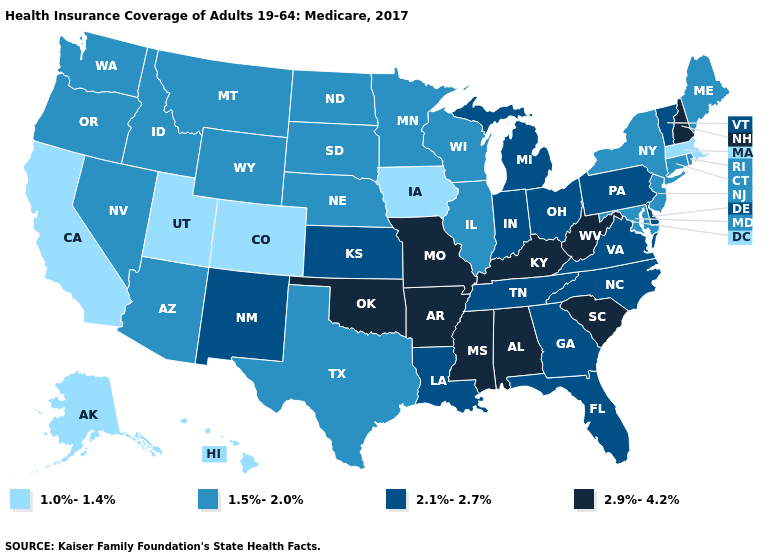Which states have the lowest value in the USA?
Answer briefly. Alaska, California, Colorado, Hawaii, Iowa, Massachusetts, Utah. Name the states that have a value in the range 1.5%-2.0%?
Quick response, please. Arizona, Connecticut, Idaho, Illinois, Maine, Maryland, Minnesota, Montana, Nebraska, Nevada, New Jersey, New York, North Dakota, Oregon, Rhode Island, South Dakota, Texas, Washington, Wisconsin, Wyoming. Name the states that have a value in the range 2.9%-4.2%?
Answer briefly. Alabama, Arkansas, Kentucky, Mississippi, Missouri, New Hampshire, Oklahoma, South Carolina, West Virginia. Does Idaho have the lowest value in the West?
Give a very brief answer. No. What is the value of Louisiana?
Quick response, please. 2.1%-2.7%. Which states have the highest value in the USA?
Quick response, please. Alabama, Arkansas, Kentucky, Mississippi, Missouri, New Hampshire, Oklahoma, South Carolina, West Virginia. What is the value of Colorado?
Give a very brief answer. 1.0%-1.4%. Which states have the lowest value in the USA?
Write a very short answer. Alaska, California, Colorado, Hawaii, Iowa, Massachusetts, Utah. What is the value of Louisiana?
Write a very short answer. 2.1%-2.7%. What is the value of Arkansas?
Keep it brief. 2.9%-4.2%. What is the value of South Dakota?
Give a very brief answer. 1.5%-2.0%. What is the highest value in states that border Arkansas?
Answer briefly. 2.9%-4.2%. Name the states that have a value in the range 1.0%-1.4%?
Quick response, please. Alaska, California, Colorado, Hawaii, Iowa, Massachusetts, Utah. What is the highest value in states that border Arizona?
Answer briefly. 2.1%-2.7%. Which states have the lowest value in the MidWest?
Short answer required. Iowa. 